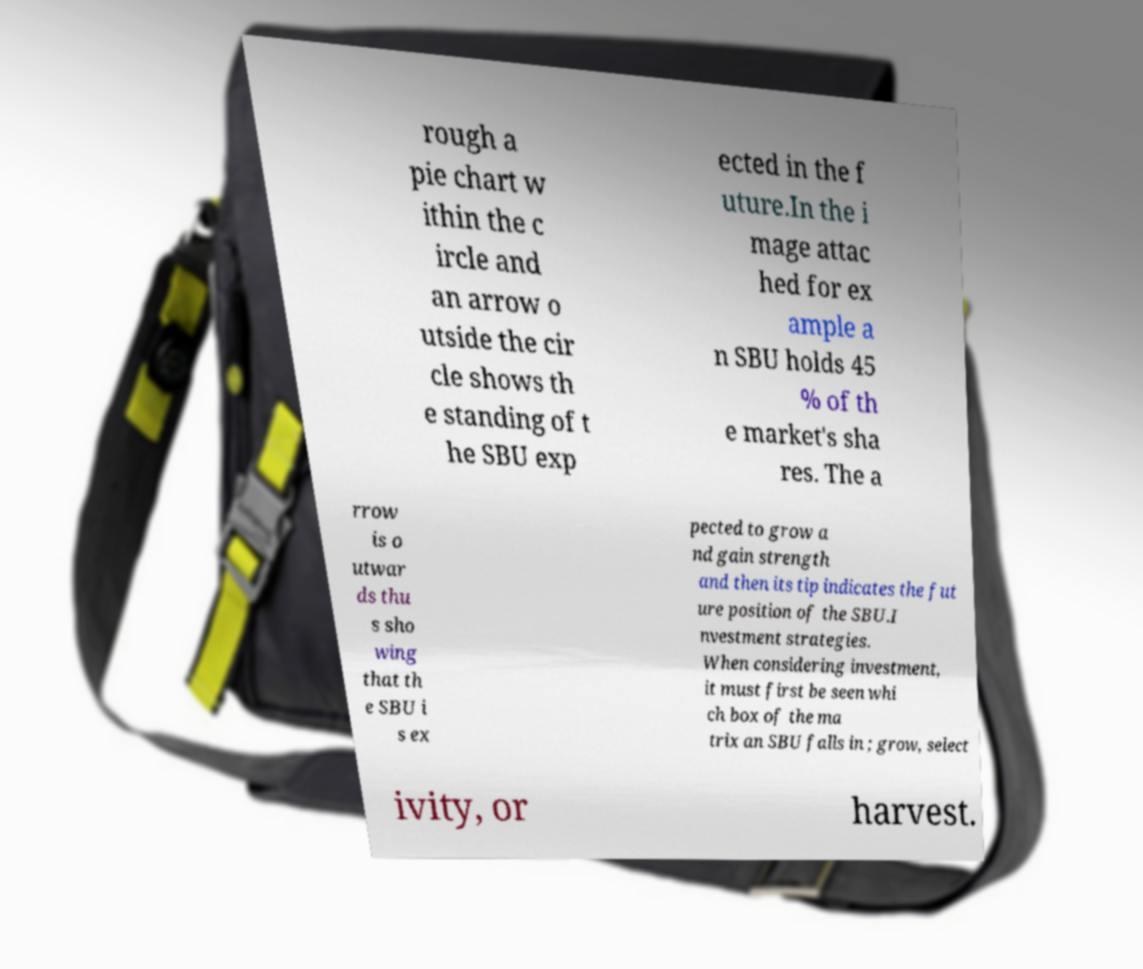Could you extract and type out the text from this image? rough a pie chart w ithin the c ircle and an arrow o utside the cir cle shows th e standing of t he SBU exp ected in the f uture.In the i mage attac hed for ex ample a n SBU holds 45 % of th e market's sha res. The a rrow is o utwar ds thu s sho wing that th e SBU i s ex pected to grow a nd gain strength and then its tip indicates the fut ure position of the SBU.I nvestment strategies. When considering investment, it must first be seen whi ch box of the ma trix an SBU falls in ; grow, select ivity, or harvest. 